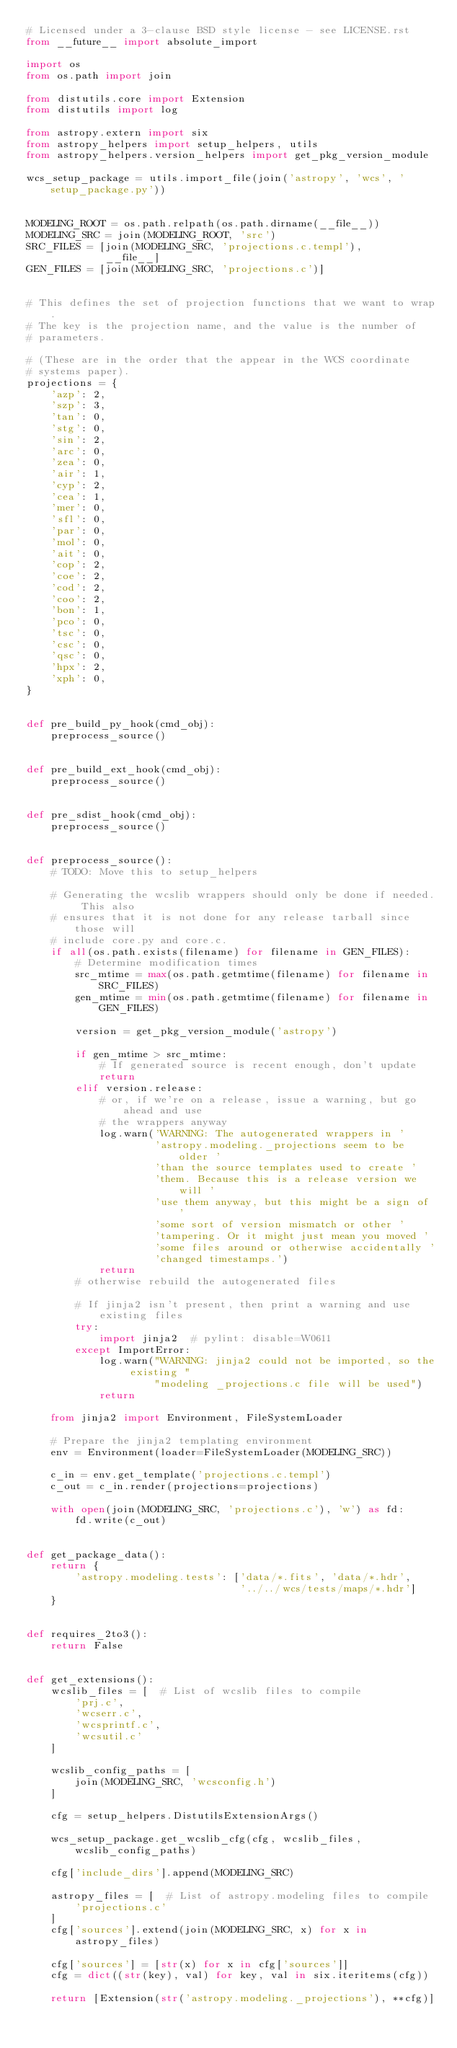<code> <loc_0><loc_0><loc_500><loc_500><_Python_># Licensed under a 3-clause BSD style license - see LICENSE.rst
from __future__ import absolute_import

import os
from os.path import join

from distutils.core import Extension
from distutils import log

from astropy.extern import six
from astropy_helpers import setup_helpers, utils
from astropy_helpers.version_helpers import get_pkg_version_module

wcs_setup_package = utils.import_file(join('astropy', 'wcs', 'setup_package.py'))


MODELING_ROOT = os.path.relpath(os.path.dirname(__file__))
MODELING_SRC = join(MODELING_ROOT, 'src')
SRC_FILES = [join(MODELING_SRC, 'projections.c.templ'),
             __file__]
GEN_FILES = [join(MODELING_SRC, 'projections.c')]


# This defines the set of projection functions that we want to wrap.
# The key is the projection name, and the value is the number of
# parameters.

# (These are in the order that the appear in the WCS coordinate
# systems paper).
projections = {
    'azp': 2,
    'szp': 3,
    'tan': 0,
    'stg': 0,
    'sin': 2,
    'arc': 0,
    'zea': 0,
    'air': 1,
    'cyp': 2,
    'cea': 1,
    'mer': 0,
    'sfl': 0,
    'par': 0,
    'mol': 0,
    'ait': 0,
    'cop': 2,
    'coe': 2,
    'cod': 2,
    'coo': 2,
    'bon': 1,
    'pco': 0,
    'tsc': 0,
    'csc': 0,
    'qsc': 0,
    'hpx': 2,
    'xph': 0,
}


def pre_build_py_hook(cmd_obj):
    preprocess_source()


def pre_build_ext_hook(cmd_obj):
    preprocess_source()


def pre_sdist_hook(cmd_obj):
    preprocess_source()


def preprocess_source():
    # TODO: Move this to setup_helpers

    # Generating the wcslib wrappers should only be done if needed. This also
    # ensures that it is not done for any release tarball since those will
    # include core.py and core.c.
    if all(os.path.exists(filename) for filename in GEN_FILES):
        # Determine modification times
        src_mtime = max(os.path.getmtime(filename) for filename in SRC_FILES)
        gen_mtime = min(os.path.getmtime(filename) for filename in GEN_FILES)

        version = get_pkg_version_module('astropy')

        if gen_mtime > src_mtime:
            # If generated source is recent enough, don't update
            return
        elif version.release:
            # or, if we're on a release, issue a warning, but go ahead and use
            # the wrappers anyway
            log.warn('WARNING: The autogenerated wrappers in '
                     'astropy.modeling._projections seem to be older '
                     'than the source templates used to create '
                     'them. Because this is a release version we will '
                     'use them anyway, but this might be a sign of '
                     'some sort of version mismatch or other '
                     'tampering. Or it might just mean you moved '
                     'some files around or otherwise accidentally '
                     'changed timestamps.')
            return
        # otherwise rebuild the autogenerated files

        # If jinja2 isn't present, then print a warning and use existing files
        try:
            import jinja2  # pylint: disable=W0611
        except ImportError:
            log.warn("WARNING: jinja2 could not be imported, so the existing "
                     "modeling _projections.c file will be used")
            return

    from jinja2 import Environment, FileSystemLoader

    # Prepare the jinja2 templating environment
    env = Environment(loader=FileSystemLoader(MODELING_SRC))

    c_in = env.get_template('projections.c.templ')
    c_out = c_in.render(projections=projections)

    with open(join(MODELING_SRC, 'projections.c'), 'w') as fd:
        fd.write(c_out)


def get_package_data():
    return {
        'astropy.modeling.tests': ['data/*.fits', 'data/*.hdr',
                                   '../../wcs/tests/maps/*.hdr']
    }


def requires_2to3():
    return False


def get_extensions():
    wcslib_files = [  # List of wcslib files to compile
        'prj.c',
        'wcserr.c',
        'wcsprintf.c',
        'wcsutil.c'
    ]

    wcslib_config_paths = [
        join(MODELING_SRC, 'wcsconfig.h')
    ]

    cfg = setup_helpers.DistutilsExtensionArgs()

    wcs_setup_package.get_wcslib_cfg(cfg, wcslib_files, wcslib_config_paths)

    cfg['include_dirs'].append(MODELING_SRC)

    astropy_files = [  # List of astropy.modeling files to compile
        'projections.c'
    ]
    cfg['sources'].extend(join(MODELING_SRC, x) for x in astropy_files)

    cfg['sources'] = [str(x) for x in cfg['sources']]
    cfg = dict((str(key), val) for key, val in six.iteritems(cfg))

    return [Extension(str('astropy.modeling._projections'), **cfg)]
</code> 